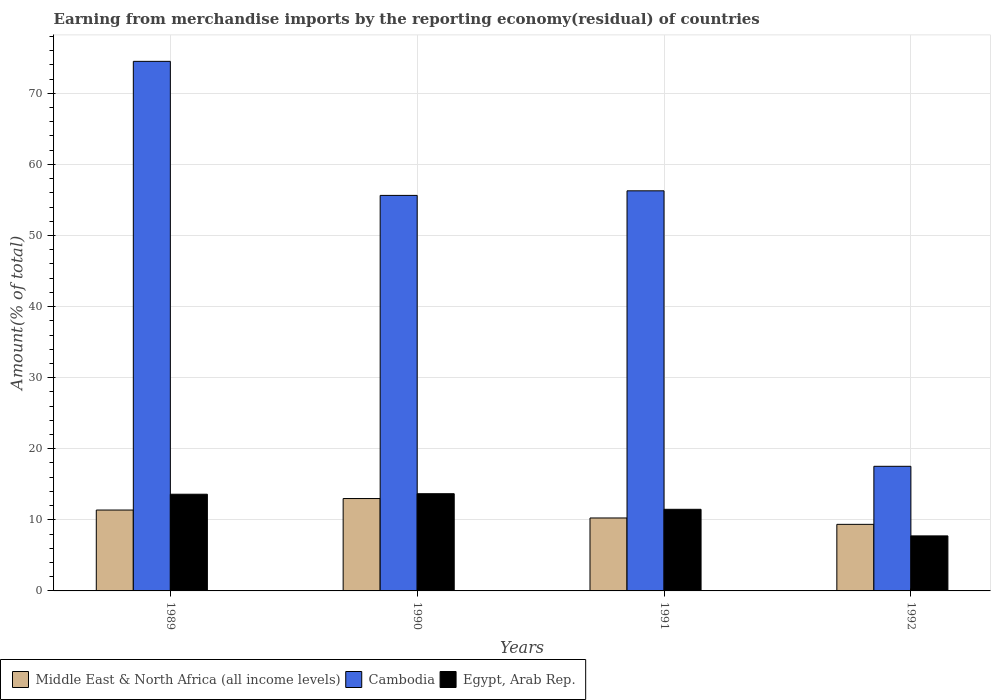How many different coloured bars are there?
Give a very brief answer. 3. Are the number of bars per tick equal to the number of legend labels?
Keep it short and to the point. Yes. Are the number of bars on each tick of the X-axis equal?
Keep it short and to the point. Yes. How many bars are there on the 3rd tick from the left?
Ensure brevity in your answer.  3. How many bars are there on the 1st tick from the right?
Your answer should be very brief. 3. What is the label of the 4th group of bars from the left?
Offer a terse response. 1992. What is the percentage of amount earned from merchandise imports in Middle East & North Africa (all income levels) in 1989?
Give a very brief answer. 11.38. Across all years, what is the maximum percentage of amount earned from merchandise imports in Cambodia?
Offer a terse response. 74.5. Across all years, what is the minimum percentage of amount earned from merchandise imports in Middle East & North Africa (all income levels)?
Your answer should be very brief. 9.36. What is the total percentage of amount earned from merchandise imports in Egypt, Arab Rep. in the graph?
Give a very brief answer. 46.5. What is the difference between the percentage of amount earned from merchandise imports in Cambodia in 1990 and that in 1991?
Give a very brief answer. -0.64. What is the difference between the percentage of amount earned from merchandise imports in Cambodia in 1991 and the percentage of amount earned from merchandise imports in Middle East & North Africa (all income levels) in 1990?
Ensure brevity in your answer.  43.29. What is the average percentage of amount earned from merchandise imports in Egypt, Arab Rep. per year?
Offer a very short reply. 11.63. In the year 1991, what is the difference between the percentage of amount earned from merchandise imports in Middle East & North Africa (all income levels) and percentage of amount earned from merchandise imports in Cambodia?
Offer a terse response. -46.02. What is the ratio of the percentage of amount earned from merchandise imports in Egypt, Arab Rep. in 1991 to that in 1992?
Your answer should be compact. 1.48. Is the percentage of amount earned from merchandise imports in Cambodia in 1989 less than that in 1990?
Provide a succinct answer. No. Is the difference between the percentage of amount earned from merchandise imports in Middle East & North Africa (all income levels) in 1989 and 1992 greater than the difference between the percentage of amount earned from merchandise imports in Cambodia in 1989 and 1992?
Offer a terse response. No. What is the difference between the highest and the second highest percentage of amount earned from merchandise imports in Middle East & North Africa (all income levels)?
Provide a succinct answer. 1.62. What is the difference between the highest and the lowest percentage of amount earned from merchandise imports in Cambodia?
Your response must be concise. 56.97. What does the 2nd bar from the left in 1989 represents?
Offer a terse response. Cambodia. What does the 3rd bar from the right in 1989 represents?
Keep it short and to the point. Middle East & North Africa (all income levels). Is it the case that in every year, the sum of the percentage of amount earned from merchandise imports in Cambodia and percentage of amount earned from merchandise imports in Middle East & North Africa (all income levels) is greater than the percentage of amount earned from merchandise imports in Egypt, Arab Rep.?
Make the answer very short. Yes. How many bars are there?
Your answer should be compact. 12. What is the difference between two consecutive major ticks on the Y-axis?
Offer a very short reply. 10. Does the graph contain grids?
Keep it short and to the point. Yes. Where does the legend appear in the graph?
Offer a terse response. Bottom left. How many legend labels are there?
Provide a succinct answer. 3. How are the legend labels stacked?
Your answer should be compact. Horizontal. What is the title of the graph?
Your answer should be compact. Earning from merchandise imports by the reporting economy(residual) of countries. Does "Mozambique" appear as one of the legend labels in the graph?
Ensure brevity in your answer.  No. What is the label or title of the Y-axis?
Your answer should be very brief. Amount(% of total). What is the Amount(% of total) of Middle East & North Africa (all income levels) in 1989?
Your answer should be compact. 11.38. What is the Amount(% of total) of Cambodia in 1989?
Your response must be concise. 74.5. What is the Amount(% of total) in Egypt, Arab Rep. in 1989?
Offer a very short reply. 13.6. What is the Amount(% of total) in Middle East & North Africa (all income levels) in 1990?
Provide a succinct answer. 13. What is the Amount(% of total) of Cambodia in 1990?
Your answer should be compact. 55.64. What is the Amount(% of total) of Egypt, Arab Rep. in 1990?
Provide a short and direct response. 13.68. What is the Amount(% of total) of Middle East & North Africa (all income levels) in 1991?
Offer a terse response. 10.26. What is the Amount(% of total) in Cambodia in 1991?
Provide a short and direct response. 56.28. What is the Amount(% of total) in Egypt, Arab Rep. in 1991?
Provide a short and direct response. 11.48. What is the Amount(% of total) of Middle East & North Africa (all income levels) in 1992?
Make the answer very short. 9.36. What is the Amount(% of total) in Cambodia in 1992?
Give a very brief answer. 17.53. What is the Amount(% of total) of Egypt, Arab Rep. in 1992?
Your response must be concise. 7.74. Across all years, what is the maximum Amount(% of total) of Middle East & North Africa (all income levels)?
Give a very brief answer. 13. Across all years, what is the maximum Amount(% of total) in Cambodia?
Offer a very short reply. 74.5. Across all years, what is the maximum Amount(% of total) in Egypt, Arab Rep.?
Offer a very short reply. 13.68. Across all years, what is the minimum Amount(% of total) in Middle East & North Africa (all income levels)?
Your answer should be compact. 9.36. Across all years, what is the minimum Amount(% of total) in Cambodia?
Your response must be concise. 17.53. Across all years, what is the minimum Amount(% of total) of Egypt, Arab Rep.?
Ensure brevity in your answer.  7.74. What is the total Amount(% of total) of Middle East & North Africa (all income levels) in the graph?
Provide a short and direct response. 44. What is the total Amount(% of total) of Cambodia in the graph?
Offer a very short reply. 203.95. What is the total Amount(% of total) of Egypt, Arab Rep. in the graph?
Your answer should be compact. 46.5. What is the difference between the Amount(% of total) in Middle East & North Africa (all income levels) in 1989 and that in 1990?
Provide a succinct answer. -1.62. What is the difference between the Amount(% of total) in Cambodia in 1989 and that in 1990?
Keep it short and to the point. 18.86. What is the difference between the Amount(% of total) of Egypt, Arab Rep. in 1989 and that in 1990?
Offer a terse response. -0.07. What is the difference between the Amount(% of total) in Middle East & North Africa (all income levels) in 1989 and that in 1991?
Provide a succinct answer. 1.11. What is the difference between the Amount(% of total) of Cambodia in 1989 and that in 1991?
Keep it short and to the point. 18.21. What is the difference between the Amount(% of total) of Egypt, Arab Rep. in 1989 and that in 1991?
Your response must be concise. 2.12. What is the difference between the Amount(% of total) of Middle East & North Africa (all income levels) in 1989 and that in 1992?
Keep it short and to the point. 2.01. What is the difference between the Amount(% of total) in Cambodia in 1989 and that in 1992?
Ensure brevity in your answer.  56.97. What is the difference between the Amount(% of total) in Egypt, Arab Rep. in 1989 and that in 1992?
Keep it short and to the point. 5.86. What is the difference between the Amount(% of total) in Middle East & North Africa (all income levels) in 1990 and that in 1991?
Make the answer very short. 2.73. What is the difference between the Amount(% of total) in Cambodia in 1990 and that in 1991?
Your response must be concise. -0.64. What is the difference between the Amount(% of total) in Egypt, Arab Rep. in 1990 and that in 1991?
Your answer should be compact. 2.19. What is the difference between the Amount(% of total) in Middle East & North Africa (all income levels) in 1990 and that in 1992?
Offer a very short reply. 3.63. What is the difference between the Amount(% of total) in Cambodia in 1990 and that in 1992?
Your answer should be compact. 38.11. What is the difference between the Amount(% of total) of Egypt, Arab Rep. in 1990 and that in 1992?
Your answer should be compact. 5.93. What is the difference between the Amount(% of total) in Middle East & North Africa (all income levels) in 1991 and that in 1992?
Your answer should be compact. 0.9. What is the difference between the Amount(% of total) in Cambodia in 1991 and that in 1992?
Offer a terse response. 38.75. What is the difference between the Amount(% of total) of Egypt, Arab Rep. in 1991 and that in 1992?
Your answer should be very brief. 3.74. What is the difference between the Amount(% of total) of Middle East & North Africa (all income levels) in 1989 and the Amount(% of total) of Cambodia in 1990?
Offer a very short reply. -44.26. What is the difference between the Amount(% of total) in Middle East & North Africa (all income levels) in 1989 and the Amount(% of total) in Egypt, Arab Rep. in 1990?
Keep it short and to the point. -2.3. What is the difference between the Amount(% of total) of Cambodia in 1989 and the Amount(% of total) of Egypt, Arab Rep. in 1990?
Ensure brevity in your answer.  60.82. What is the difference between the Amount(% of total) in Middle East & North Africa (all income levels) in 1989 and the Amount(% of total) in Cambodia in 1991?
Make the answer very short. -44.91. What is the difference between the Amount(% of total) of Middle East & North Africa (all income levels) in 1989 and the Amount(% of total) of Egypt, Arab Rep. in 1991?
Make the answer very short. -0.1. What is the difference between the Amount(% of total) of Cambodia in 1989 and the Amount(% of total) of Egypt, Arab Rep. in 1991?
Keep it short and to the point. 63.01. What is the difference between the Amount(% of total) in Middle East & North Africa (all income levels) in 1989 and the Amount(% of total) in Cambodia in 1992?
Give a very brief answer. -6.15. What is the difference between the Amount(% of total) of Middle East & North Africa (all income levels) in 1989 and the Amount(% of total) of Egypt, Arab Rep. in 1992?
Offer a very short reply. 3.64. What is the difference between the Amount(% of total) of Cambodia in 1989 and the Amount(% of total) of Egypt, Arab Rep. in 1992?
Your response must be concise. 66.76. What is the difference between the Amount(% of total) of Middle East & North Africa (all income levels) in 1990 and the Amount(% of total) of Cambodia in 1991?
Offer a terse response. -43.29. What is the difference between the Amount(% of total) of Middle East & North Africa (all income levels) in 1990 and the Amount(% of total) of Egypt, Arab Rep. in 1991?
Give a very brief answer. 1.51. What is the difference between the Amount(% of total) in Cambodia in 1990 and the Amount(% of total) in Egypt, Arab Rep. in 1991?
Your answer should be compact. 44.16. What is the difference between the Amount(% of total) of Middle East & North Africa (all income levels) in 1990 and the Amount(% of total) of Cambodia in 1992?
Give a very brief answer. -4.54. What is the difference between the Amount(% of total) of Middle East & North Africa (all income levels) in 1990 and the Amount(% of total) of Egypt, Arab Rep. in 1992?
Provide a short and direct response. 5.25. What is the difference between the Amount(% of total) of Cambodia in 1990 and the Amount(% of total) of Egypt, Arab Rep. in 1992?
Give a very brief answer. 47.9. What is the difference between the Amount(% of total) of Middle East & North Africa (all income levels) in 1991 and the Amount(% of total) of Cambodia in 1992?
Offer a terse response. -7.27. What is the difference between the Amount(% of total) in Middle East & North Africa (all income levels) in 1991 and the Amount(% of total) in Egypt, Arab Rep. in 1992?
Ensure brevity in your answer.  2.52. What is the difference between the Amount(% of total) in Cambodia in 1991 and the Amount(% of total) in Egypt, Arab Rep. in 1992?
Offer a terse response. 48.54. What is the average Amount(% of total) in Middle East & North Africa (all income levels) per year?
Ensure brevity in your answer.  11. What is the average Amount(% of total) of Cambodia per year?
Ensure brevity in your answer.  50.99. What is the average Amount(% of total) of Egypt, Arab Rep. per year?
Ensure brevity in your answer.  11.63. In the year 1989, what is the difference between the Amount(% of total) in Middle East & North Africa (all income levels) and Amount(% of total) in Cambodia?
Keep it short and to the point. -63.12. In the year 1989, what is the difference between the Amount(% of total) in Middle East & North Africa (all income levels) and Amount(% of total) in Egypt, Arab Rep.?
Your answer should be compact. -2.22. In the year 1989, what is the difference between the Amount(% of total) in Cambodia and Amount(% of total) in Egypt, Arab Rep.?
Give a very brief answer. 60.89. In the year 1990, what is the difference between the Amount(% of total) in Middle East & North Africa (all income levels) and Amount(% of total) in Cambodia?
Ensure brevity in your answer.  -42.65. In the year 1990, what is the difference between the Amount(% of total) of Middle East & North Africa (all income levels) and Amount(% of total) of Egypt, Arab Rep.?
Offer a terse response. -0.68. In the year 1990, what is the difference between the Amount(% of total) of Cambodia and Amount(% of total) of Egypt, Arab Rep.?
Ensure brevity in your answer.  41.97. In the year 1991, what is the difference between the Amount(% of total) in Middle East & North Africa (all income levels) and Amount(% of total) in Cambodia?
Your answer should be very brief. -46.02. In the year 1991, what is the difference between the Amount(% of total) of Middle East & North Africa (all income levels) and Amount(% of total) of Egypt, Arab Rep.?
Make the answer very short. -1.22. In the year 1991, what is the difference between the Amount(% of total) in Cambodia and Amount(% of total) in Egypt, Arab Rep.?
Offer a terse response. 44.8. In the year 1992, what is the difference between the Amount(% of total) in Middle East & North Africa (all income levels) and Amount(% of total) in Cambodia?
Offer a very short reply. -8.17. In the year 1992, what is the difference between the Amount(% of total) in Middle East & North Africa (all income levels) and Amount(% of total) in Egypt, Arab Rep.?
Give a very brief answer. 1.62. In the year 1992, what is the difference between the Amount(% of total) of Cambodia and Amount(% of total) of Egypt, Arab Rep.?
Ensure brevity in your answer.  9.79. What is the ratio of the Amount(% of total) of Middle East & North Africa (all income levels) in 1989 to that in 1990?
Give a very brief answer. 0.88. What is the ratio of the Amount(% of total) of Cambodia in 1989 to that in 1990?
Provide a short and direct response. 1.34. What is the ratio of the Amount(% of total) in Middle East & North Africa (all income levels) in 1989 to that in 1991?
Offer a very short reply. 1.11. What is the ratio of the Amount(% of total) of Cambodia in 1989 to that in 1991?
Your answer should be very brief. 1.32. What is the ratio of the Amount(% of total) of Egypt, Arab Rep. in 1989 to that in 1991?
Ensure brevity in your answer.  1.18. What is the ratio of the Amount(% of total) of Middle East & North Africa (all income levels) in 1989 to that in 1992?
Provide a short and direct response. 1.21. What is the ratio of the Amount(% of total) in Cambodia in 1989 to that in 1992?
Your answer should be very brief. 4.25. What is the ratio of the Amount(% of total) in Egypt, Arab Rep. in 1989 to that in 1992?
Provide a short and direct response. 1.76. What is the ratio of the Amount(% of total) in Middle East & North Africa (all income levels) in 1990 to that in 1991?
Offer a terse response. 1.27. What is the ratio of the Amount(% of total) in Cambodia in 1990 to that in 1991?
Offer a terse response. 0.99. What is the ratio of the Amount(% of total) of Egypt, Arab Rep. in 1990 to that in 1991?
Keep it short and to the point. 1.19. What is the ratio of the Amount(% of total) in Middle East & North Africa (all income levels) in 1990 to that in 1992?
Your answer should be very brief. 1.39. What is the ratio of the Amount(% of total) in Cambodia in 1990 to that in 1992?
Provide a short and direct response. 3.17. What is the ratio of the Amount(% of total) in Egypt, Arab Rep. in 1990 to that in 1992?
Provide a succinct answer. 1.77. What is the ratio of the Amount(% of total) in Middle East & North Africa (all income levels) in 1991 to that in 1992?
Offer a terse response. 1.1. What is the ratio of the Amount(% of total) in Cambodia in 1991 to that in 1992?
Offer a terse response. 3.21. What is the ratio of the Amount(% of total) in Egypt, Arab Rep. in 1991 to that in 1992?
Make the answer very short. 1.48. What is the difference between the highest and the second highest Amount(% of total) of Middle East & North Africa (all income levels)?
Your answer should be very brief. 1.62. What is the difference between the highest and the second highest Amount(% of total) of Cambodia?
Your answer should be compact. 18.21. What is the difference between the highest and the second highest Amount(% of total) of Egypt, Arab Rep.?
Offer a very short reply. 0.07. What is the difference between the highest and the lowest Amount(% of total) of Middle East & North Africa (all income levels)?
Provide a succinct answer. 3.63. What is the difference between the highest and the lowest Amount(% of total) of Cambodia?
Your answer should be compact. 56.97. What is the difference between the highest and the lowest Amount(% of total) of Egypt, Arab Rep.?
Your answer should be very brief. 5.93. 